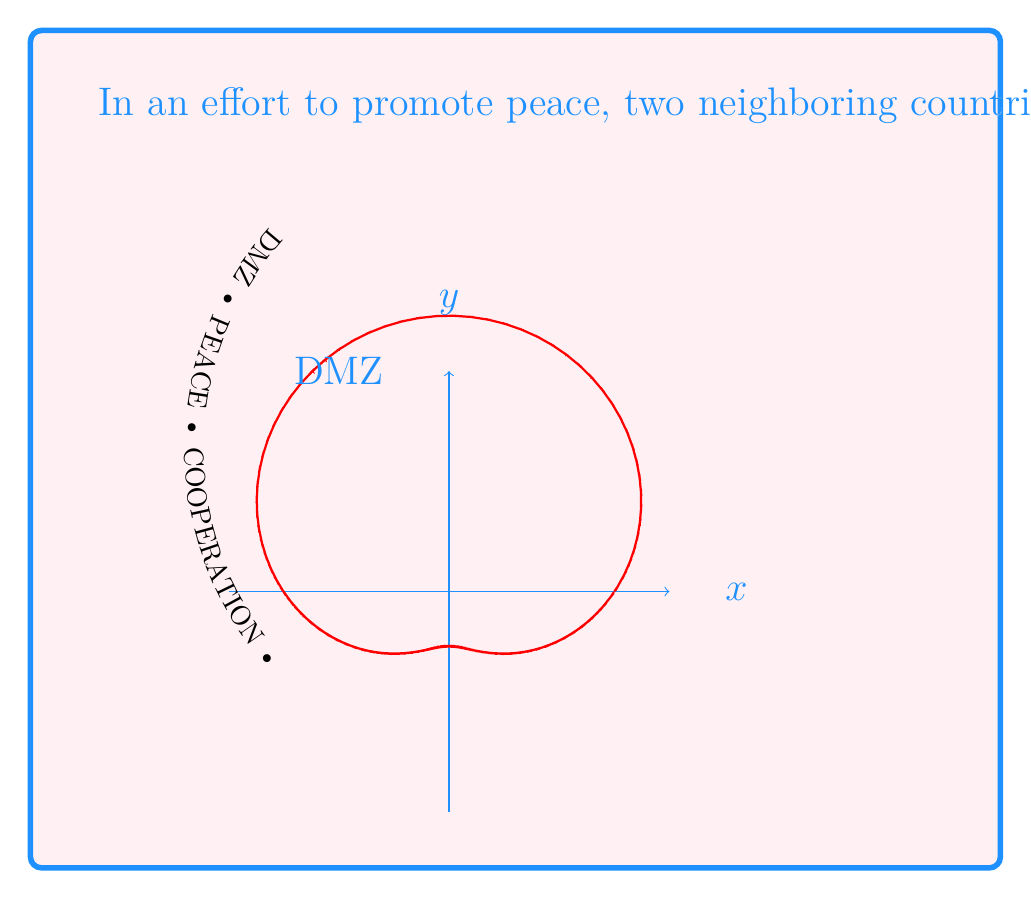Show me your answer to this math problem. To determine the area of the region defined by a polar equation, we use the formula:

$$ A = \frac{1}{2} \int_{0}^{2\pi} r^2(\theta) d\theta $$

Where $r(\theta) = 3 + 2\sin(\theta)$

Step 1: Square the polar equation
$r^2(\theta) = (3 + 2\sin(\theta))^2 = 9 + 12\sin(\theta) + 4\sin^2(\theta)$

Step 2: Set up the integral
$$ A = \frac{1}{2} \int_{0}^{2\pi} (9 + 12\sin(\theta) + 4\sin^2(\theta)) d\theta $$

Step 3: Integrate each term
- $\int_{0}^{2\pi} 9 d\theta = 9\theta \big|_{0}^{2\pi} = 18\pi$
- $\int_{0}^{2\pi} 12\sin(\theta) d\theta = -12\cos(\theta) \big|_{0}^{2\pi} = 0$
- $\int_{0}^{2\pi} 4\sin^2(\theta) d\theta = 2\theta - 2\sin(\theta)\cos(\theta) \big|_{0}^{2\pi} = 4\pi$

Step 4: Sum the results and multiply by $\frac{1}{2}$
$$ A = \frac{1}{2}(18\pi + 0 + 4\pi) = 11\pi $$

Step 5: Convert to square kilometers (1 km² ≈ 3.14 km²)
$A \approx 34.54$ km²

Step 6: Round to the nearest square kilometer
$A \approx 35$ km²
Answer: 35 km² 